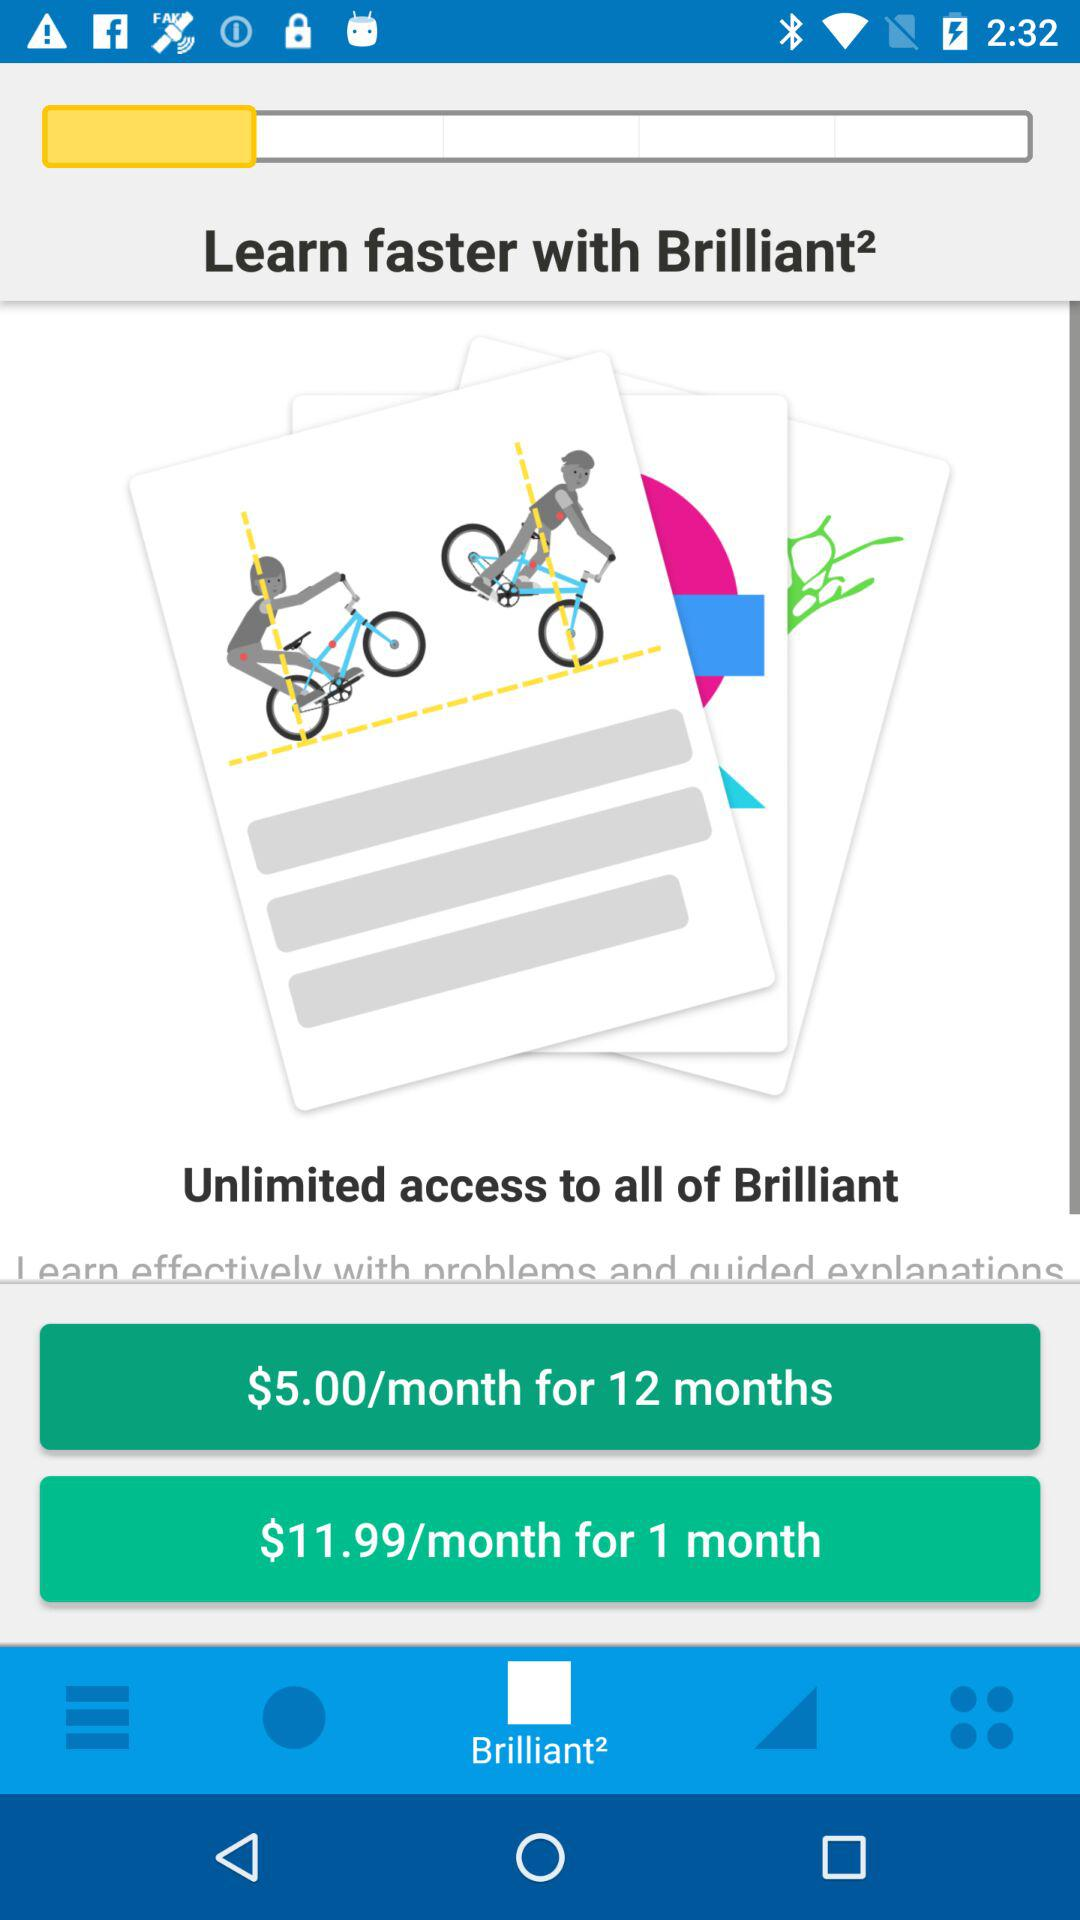How much does a 12-month subscription cost per month? A 12-month subscription costs $5.00 per month. 